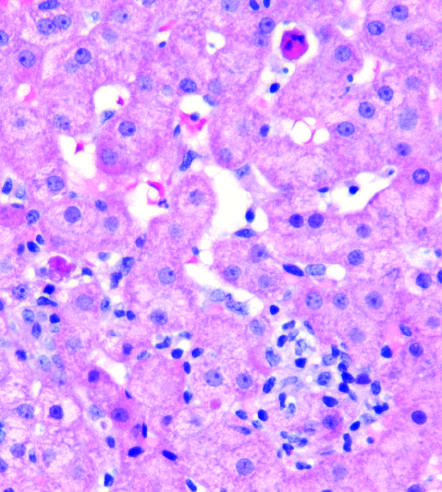what shows scattered apoptotic hepatocytes and a patchy inflammatory infiltrate?
Answer the question using a single word or phrase. The biopsy from a patient with lobular hepatitis due chronic hepatitis c 